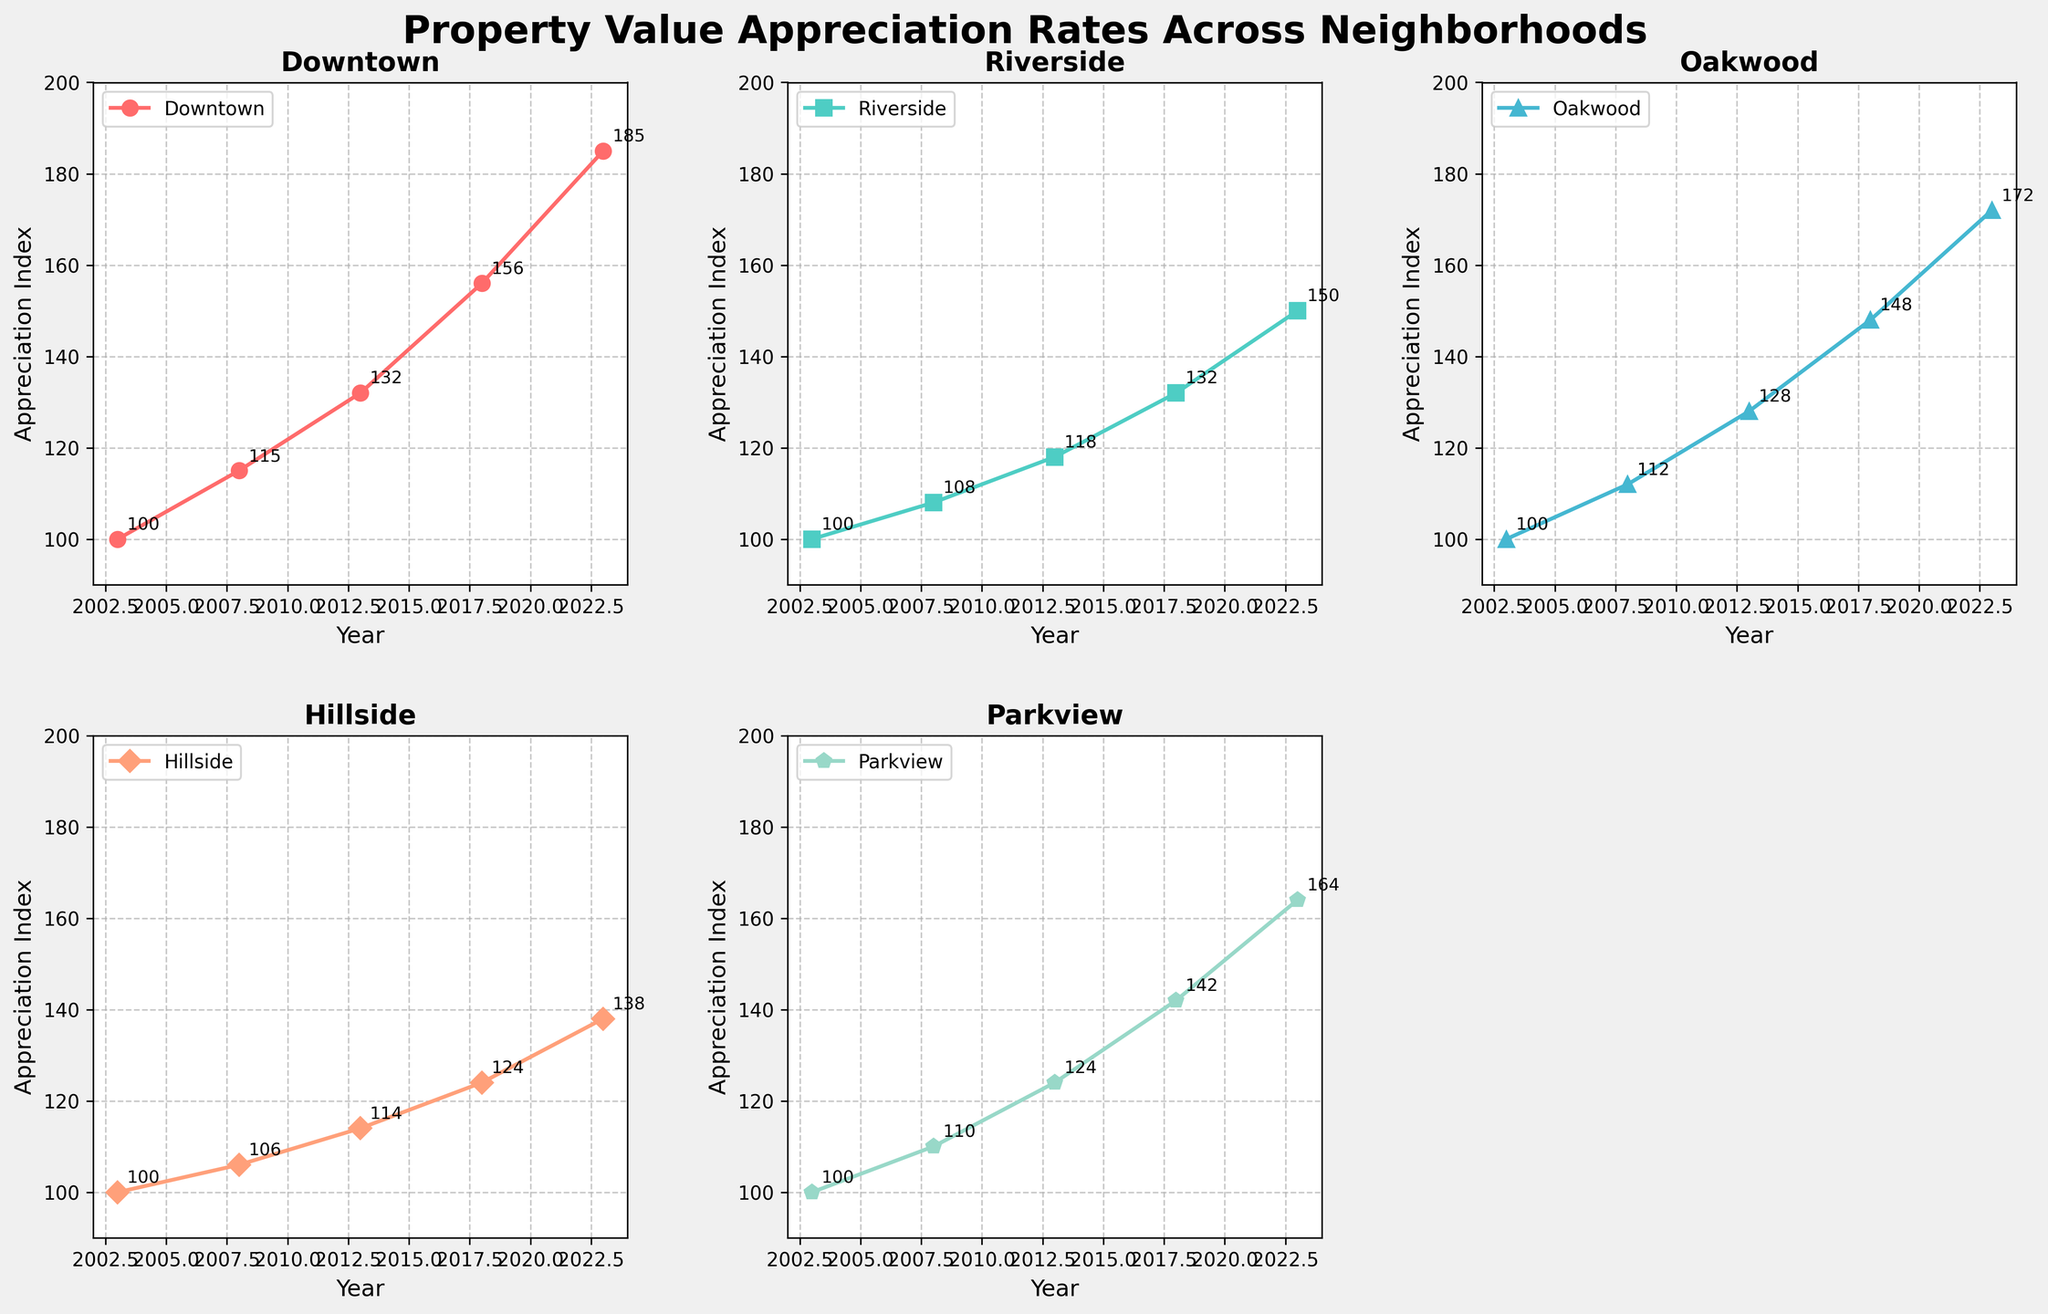Which neighborhood had the highest property value appreciation in 2023? Refer to the figure's subplots. The highest appreciation in 2023 can be found by identifying the neighborhood with the highest index value on the Y-axis. Downtown shows the highest value of 185 among the neighborhoods.
Answer: Downtown How many neighborhoods are compared in the figure? Look at the number of subplots in the figure and count them. There are five subplots, each representing a different neighborhood.
Answer: 5 In which year did Oakwood’s property value index cross 120? Trace the Oakwood plot and observe the Y-values. Oakwood's value exceeded 120 for the first time in 2013 when its index was 128.
Answer: 2013 What is the difference in property value index between Downtown and Riverside in 2018? Check the values for 2018 in Downtown and Riverside subplots. Subtract Riverside's value (132) from Downtown's value (156). The difference is 24.
Answer: 24 Which neighborhood had the least appreciation in 2008? Refer to 2008 values in all subplots. Hillside had a value of 106 in 2008, which is the lowest among all neighborhoods.
Answer: Hillside What is the average property value index of Parkview over the years presented? Identify Parkview's index values for each year: 100, 110, 124, 142, 164. Calculate the average: (100 + 110 + 124 + 142 + 164) / 5 = 128.
Answer: 128 How much did Hillside's property value index increase from 2003 to 2023? Check Hillside's values for 2003 and 2023. Subtract the 2003 value (100) from the 2023 value (138). The increase is 38.
Answer: 38 Which year had the closest property value index between Downtown and Oakwood? Compare the values for Downtown and Oakwood for each year. In 2018, Downtown’s value is 156, and Oakwood’s value is 148. The difference is 8, which is the closest among the years examined.
Answer: 2018 